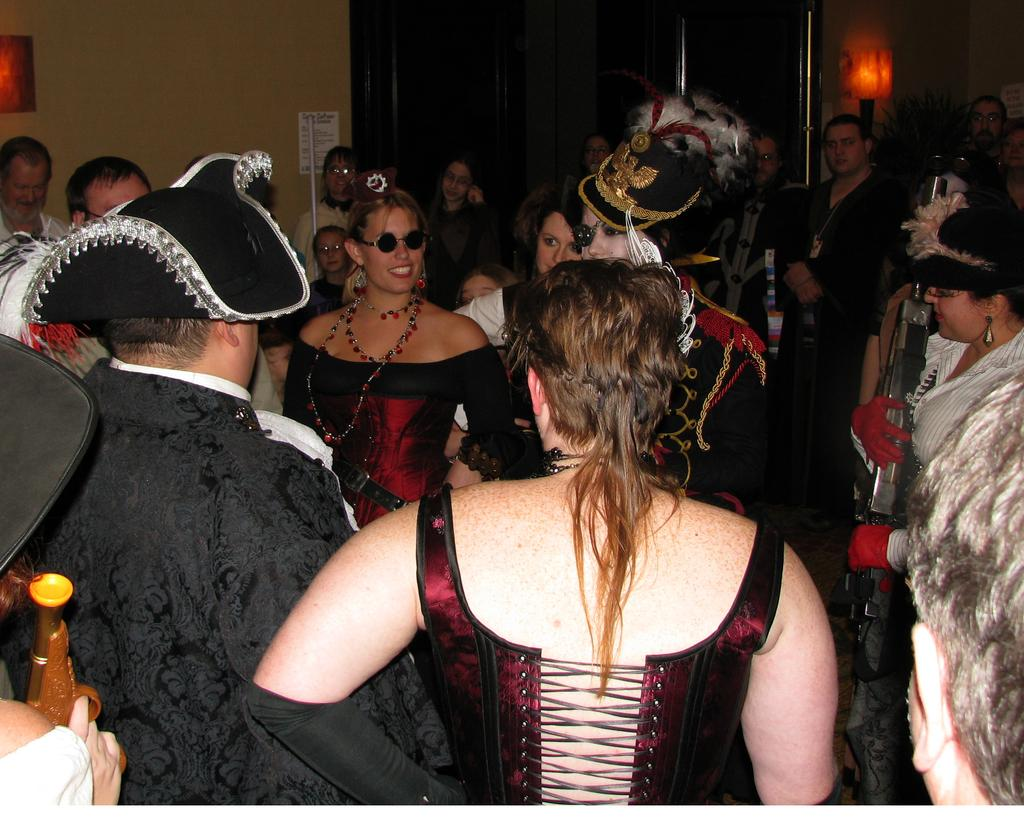What can be seen in the image in terms of people? There are groups of people in the image. What type of clothing accessory is visible on some of the people? There are hats visible in the image. What type of structure is present in the image? There is a wall in the image. What type of signage is present in the image? There is a poster in the image. What type of meal is being prepared in the image? There is no meal preparation visible in the image. What type of ice can be seen in the image? There is no ice present in the image. 